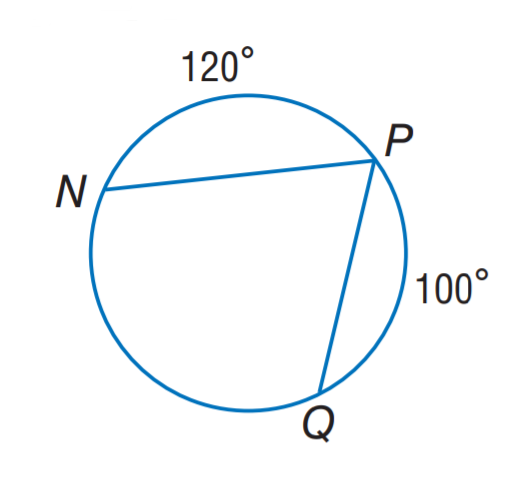Question: Find m \angle P.
Choices:
A. 60
B. 70
C. 100
D. 120
Answer with the letter. Answer: B 